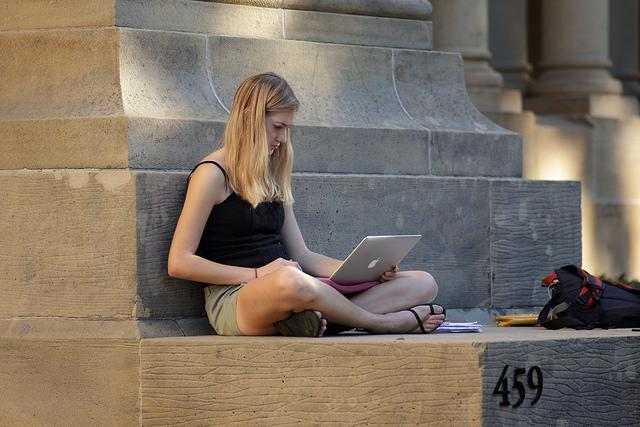How might this person easily look up the phone number for a taxi? Please explain your reasoning. google it. This person might google the taxi phone number. 